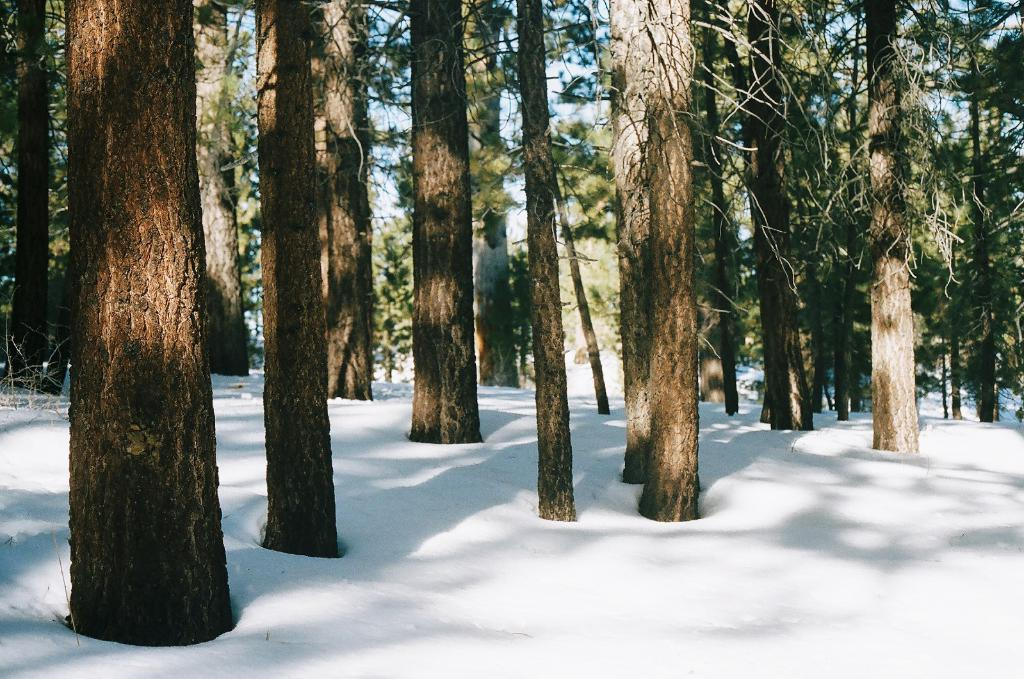What can be seen in the sky in the image? The sky is visible in the image. What type of vegetation is present in the image? There are trees in the image. What is the weather condition in the image? There is snow in the image, indicating a cold or wintry condition. How many bikes are parked under the trees in the image? There are no bikes present in the image; it only features the sky, trees, and snow. 